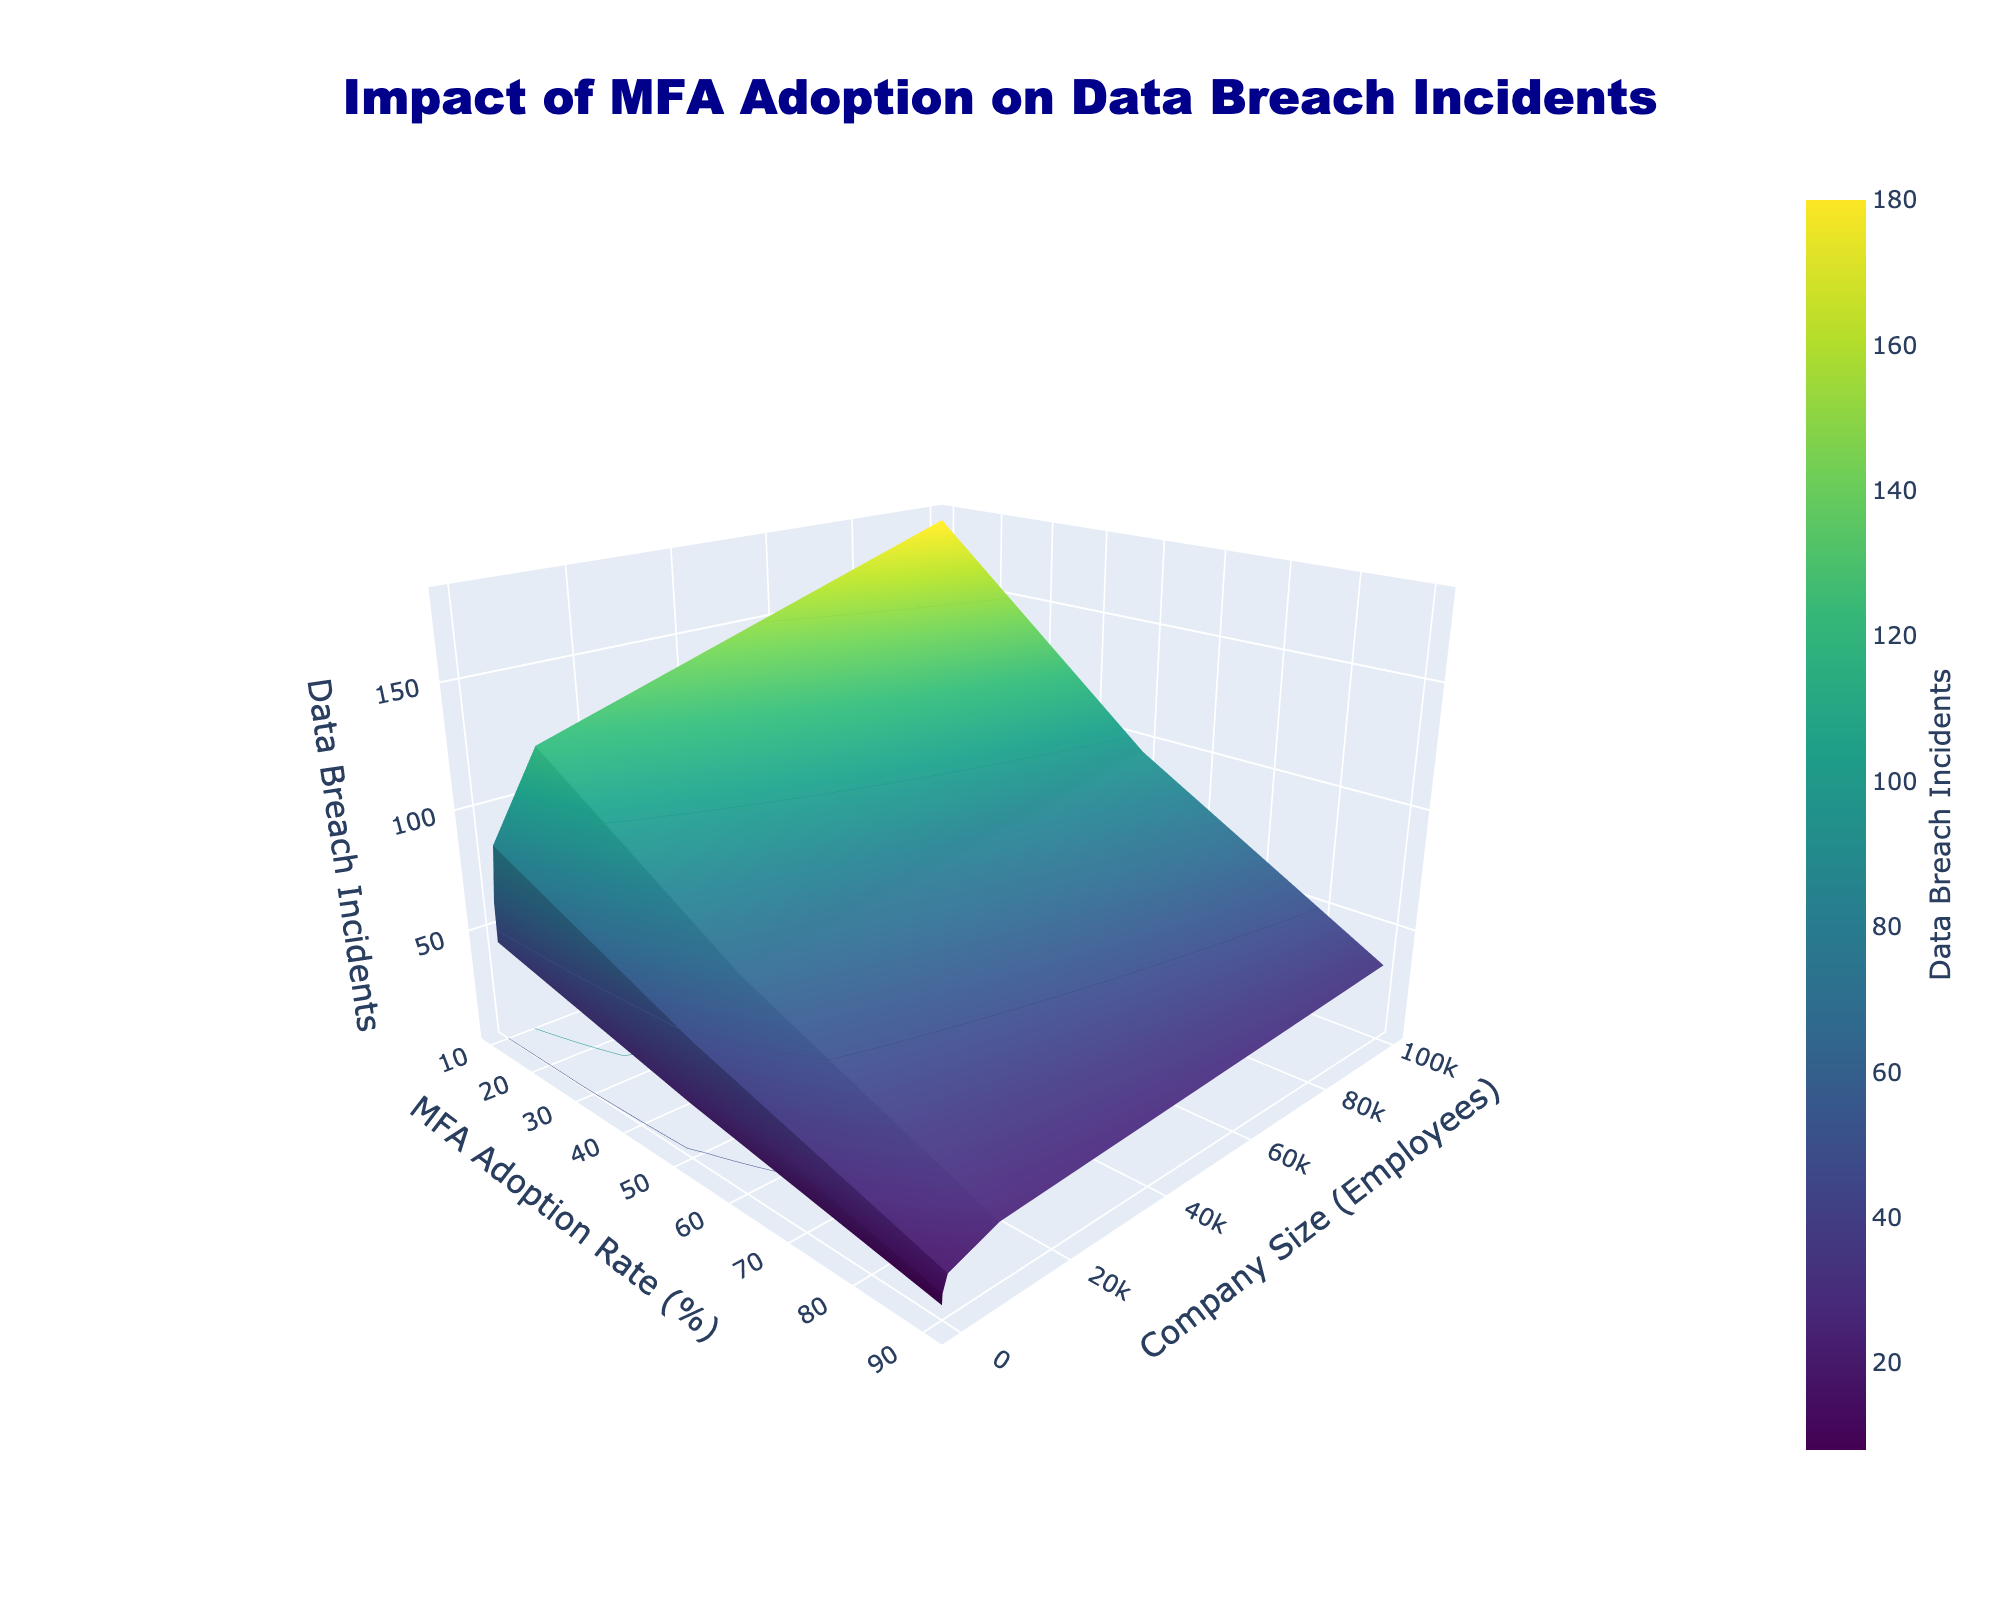What is the title of the plot? The title of the plot is generally displayed at the top of the figure. Here it is seen as ‘Impact of MFA Adoption on Data Breach Incidents’.
Answer: Impact of MFA Adoption on Data Breach Incidents What does the x-axis represent? The x-axis typically is labeled with its meaning. In this plot, it represents 'MFA Adoption Rate (%)'.
Answer: MFA Adoption Rate (%) What does the color scale indicate? The color scale in the plot is shown to represent the number of 'Data Breach Incidents' across different variables. The color shift helps differentiate the magnitude visually.
Answer: Data Breach Incidents Which company size witnessed the highest number of data breaches at 10% MFA adoption rate? To find the answer, we note the highest peak along the z-axis for the 10% MFA adoption rate. For the company size of 100000 employees, the maximum breach incidents, 180, are observed.
Answer: 100000 employees How many levels of MFA adoption rates are shown in the figure? Based on the distinct ticks on the x-axis (MFA Adoption Rate), we see 3 levels, representing 10%, 50%, and 90%.
Answer: 3 If a company of size 1000 increases its MFA adoption rate from 10% to 90%, how many breaches are reduced? To solve, observe breach incidents for 1000 employees at 10% (85 incidents) and 90% (18 incidents), then find the difference (85 - 18).
Answer: 67 incidents Compare the data breach incidents for a company of size 100 at both 10% and 50% MFA adoption rates. Which rate results in lower incidents? By comparing the labels across two MFA adoption rates for company size 100, 62 incidents are noted at 10% and 35 at 50%. Therefore, 50% MFA reduces incidents significantly.
Answer: 50% For a company size of 10000, what's the difference in data breach incidents between MFA adoption rates of 50% and 90%? Data breach incidents for 50% MFA are 65 and for 90% MFA are 25. The difference is computed (65 - 25).
Answer: 40 incidents How does the overall trend appear when increasing MFA adoption across all company sizes? By examining the surface plot, it generally appears that increasing MFA adoption reduces data breach incidents consistently, depicted by decreasing height and color intensity.
Answer: Decrease in incidents 